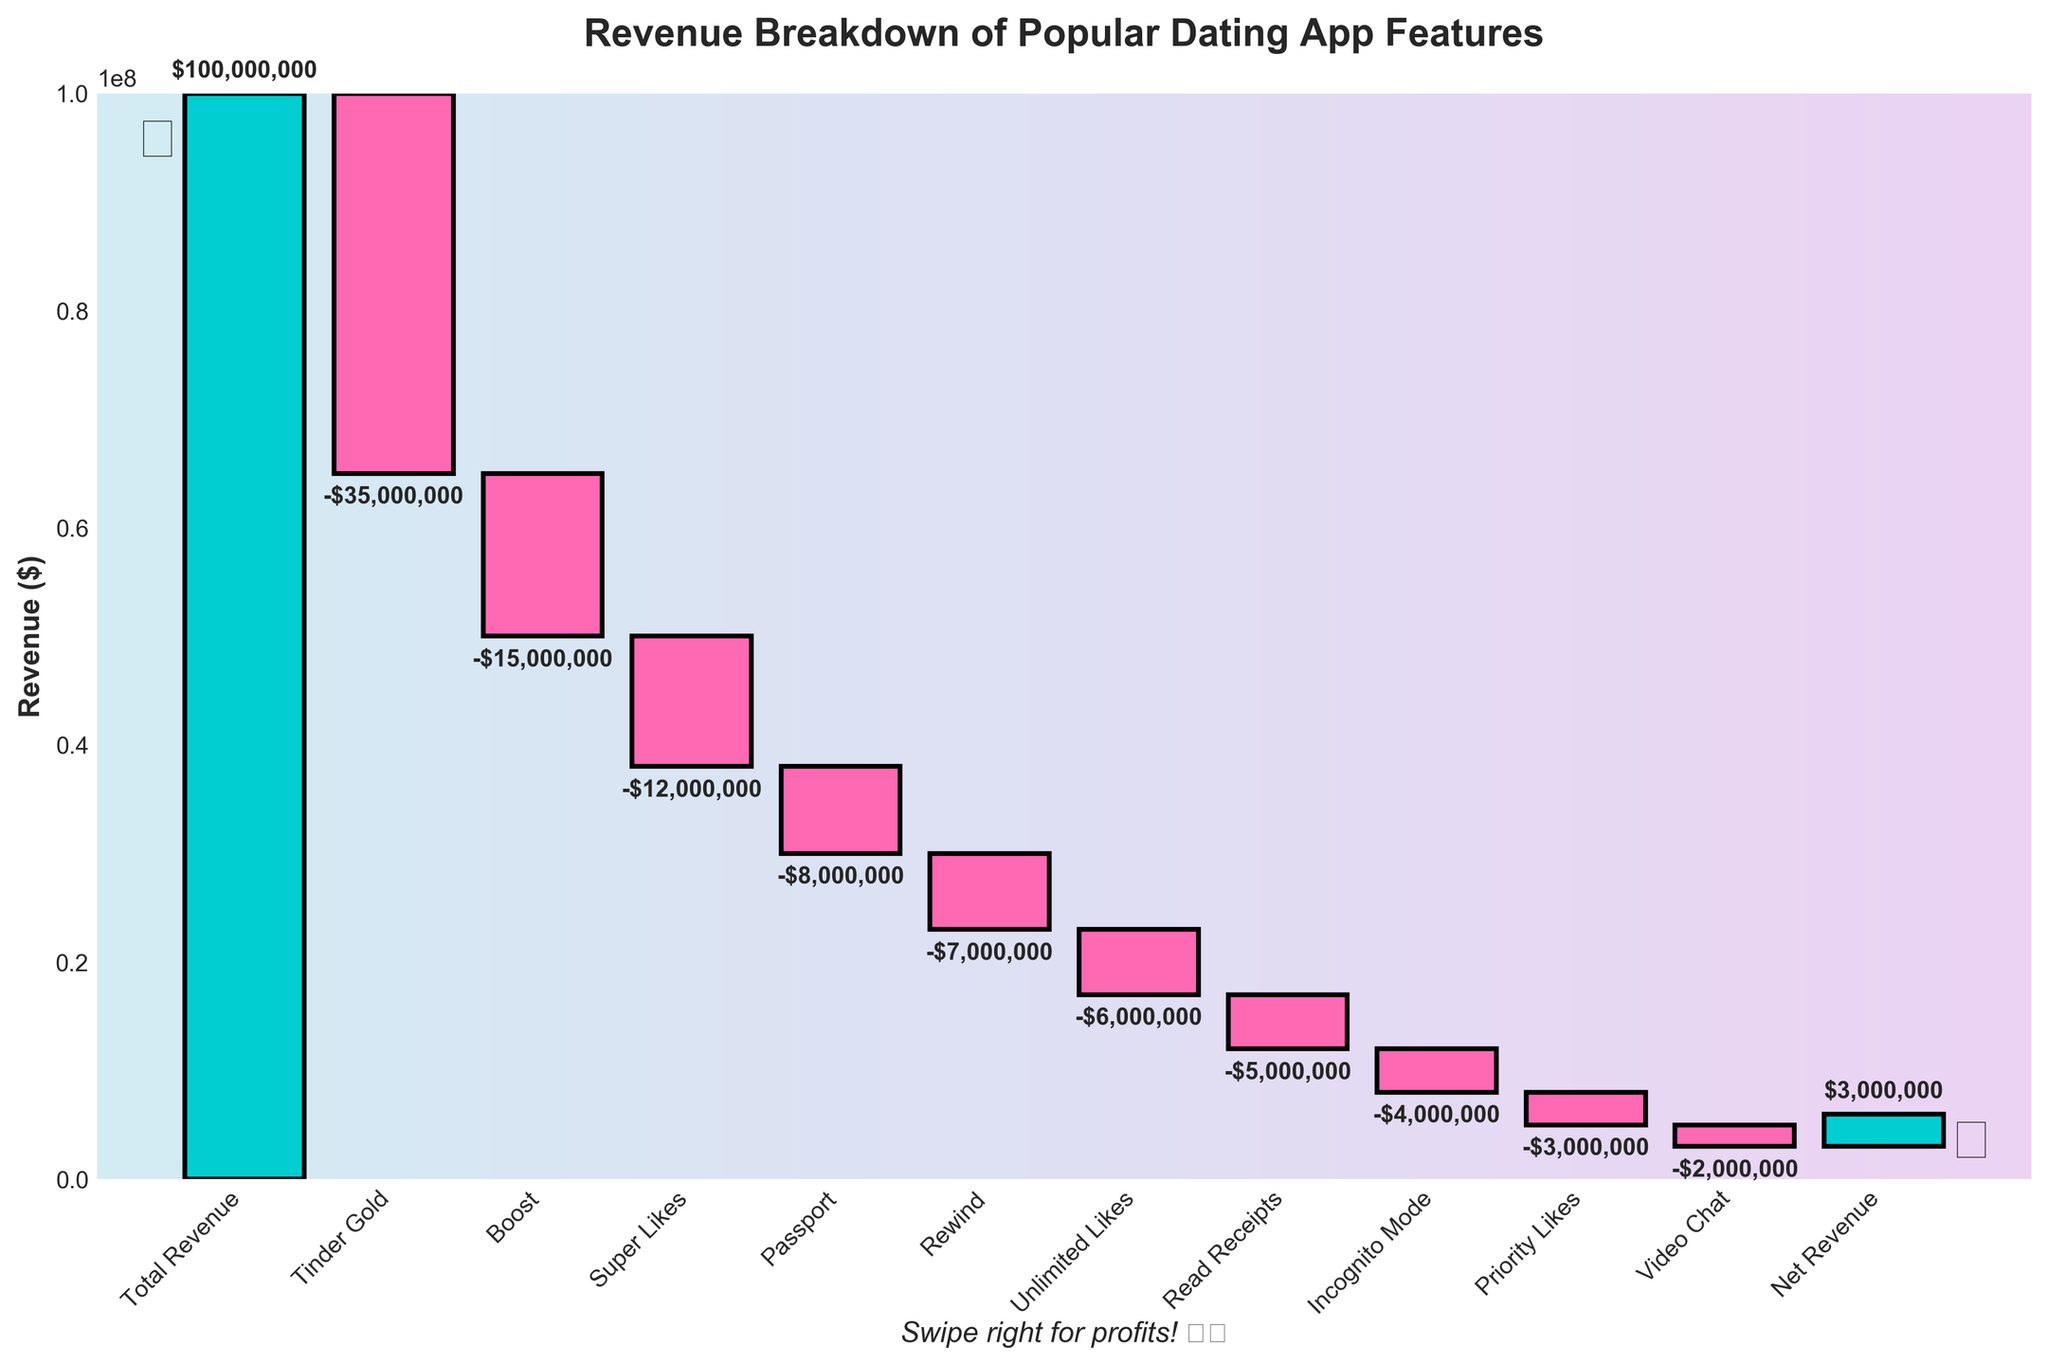what is the title of the chart? The title of the chart is prominently displayed at the top and reads "Revenue Breakdown of Popular Dating App Features".
Answer: Revenue Breakdown of Popular Dating App Features How much revenue did Tinder Gold generate? The bar for Tinder Gold shows a negative value. The labeled annotation states '-$35,000,000'.
Answer: -$35,000,000 What is the net revenue? At the far right of the chart, the bar for Net Revenue is displayed with an annotation stating '$3,000,000'.
Answer: $3,000,000 Which feature subscription added the least revenue? The bar for Video Chat shows the smallest decrement with a label of '-$2,000,000'.
Answer: Video Chat How many features are listed and compared in the chart? Counting all the bars in the chart gives a total of 11 feature subscriptions listed.
Answer: 11 Did the Passport feature generate more or less revenue than the Rewind feature? Comparing the annotations on the bars, Passport is labelled with '-$8,000,000' and Rewind with '-$7,000,000'. Passport generated less revenue than Rewind.
Answer: Less What is the combined revenue of Boost, Super Likes, and Passport? Add the values together: -$15,000,000 (Boost) + -$12,000,000 (Super Likes) + -$8,000,000 (Passport) = -$35,000,000.
Answer: -$35,000,000 By how much does the revenue from Incognito Mode differ from Unlimited Likes? Subtract the values: -$6,000,000 (Unlimited Likes) - -$4,000,000 (Incognito Mode) = -$2,000,000.
Answer: $2,000,000 Among the features listed, which one contributed the highest revenue reduction? The largest negative bar corresponds to Tinder Gold with '-$35,000,000'.
Answer: Tinder Gold How much did Priority Likes and Read Receipts contribute together? Adding the two values: -$3,000,000 (Priority Likes) + -$5,000,000 (Read Receipts) = -$8,000,000.
Answer: -$8,000,000 